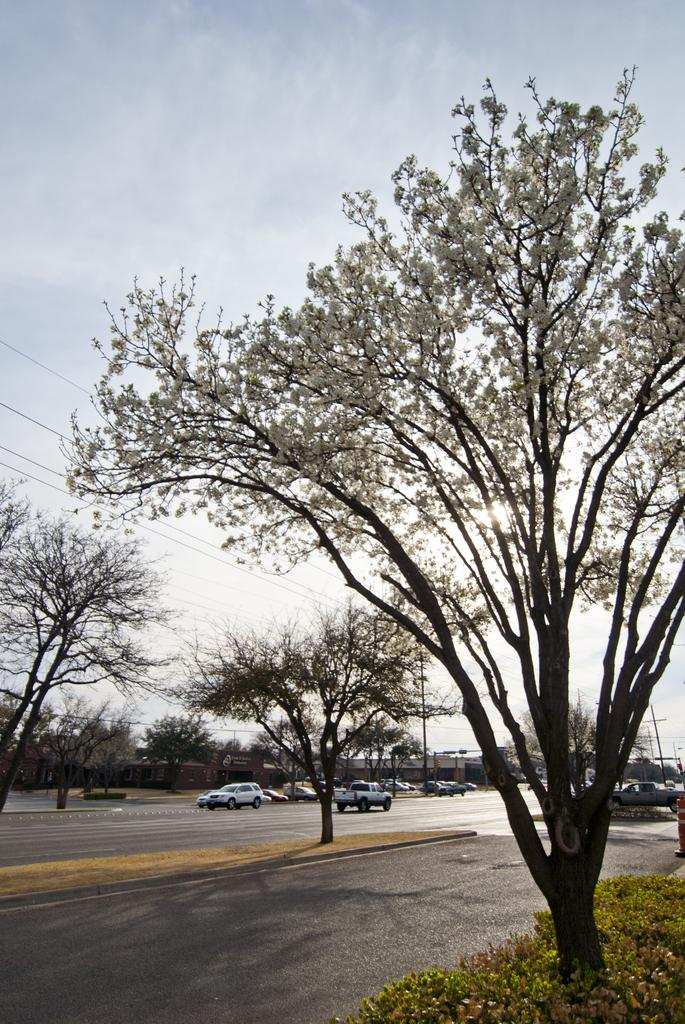What can be seen on the road in the image? There are vehicles on the road in the image. What type of vegetation is present in the image? There are trees, plants, and grass in the image. What structures can be seen in the image? There are poles and at least one building in the image. What part of the natural environment is visible in the image? The sky is visible in the image. What advice is the sun giving to the vehicles in the image? There is no sun present in the image, and therefore no advice can be given. What addition can be made to the image to make it more colorful? The question is not about the image itself, but rather about making a hypothetical change to it. The image as it is does not require any additions to be more colorful, as the colors present are sufficient to convey the scene. 